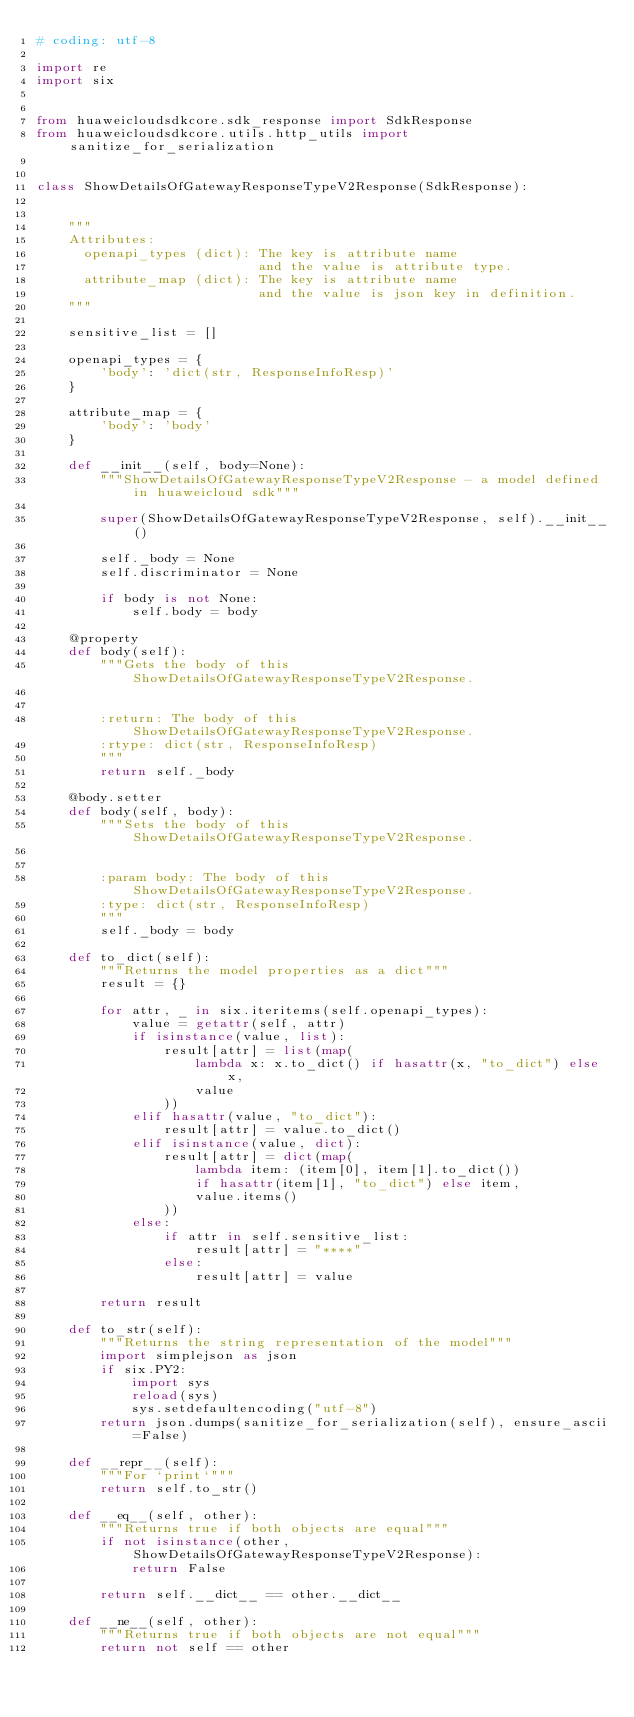<code> <loc_0><loc_0><loc_500><loc_500><_Python_># coding: utf-8

import re
import six


from huaweicloudsdkcore.sdk_response import SdkResponse
from huaweicloudsdkcore.utils.http_utils import sanitize_for_serialization


class ShowDetailsOfGatewayResponseTypeV2Response(SdkResponse):


    """
    Attributes:
      openapi_types (dict): The key is attribute name
                            and the value is attribute type.
      attribute_map (dict): The key is attribute name
                            and the value is json key in definition.
    """

    sensitive_list = []

    openapi_types = {
        'body': 'dict(str, ResponseInfoResp)'
    }

    attribute_map = {
        'body': 'body'
    }

    def __init__(self, body=None):
        """ShowDetailsOfGatewayResponseTypeV2Response - a model defined in huaweicloud sdk"""
        
        super(ShowDetailsOfGatewayResponseTypeV2Response, self).__init__()

        self._body = None
        self.discriminator = None

        if body is not None:
            self.body = body

    @property
    def body(self):
        """Gets the body of this ShowDetailsOfGatewayResponseTypeV2Response.


        :return: The body of this ShowDetailsOfGatewayResponseTypeV2Response.
        :rtype: dict(str, ResponseInfoResp)
        """
        return self._body

    @body.setter
    def body(self, body):
        """Sets the body of this ShowDetailsOfGatewayResponseTypeV2Response.


        :param body: The body of this ShowDetailsOfGatewayResponseTypeV2Response.
        :type: dict(str, ResponseInfoResp)
        """
        self._body = body

    def to_dict(self):
        """Returns the model properties as a dict"""
        result = {}

        for attr, _ in six.iteritems(self.openapi_types):
            value = getattr(self, attr)
            if isinstance(value, list):
                result[attr] = list(map(
                    lambda x: x.to_dict() if hasattr(x, "to_dict") else x,
                    value
                ))
            elif hasattr(value, "to_dict"):
                result[attr] = value.to_dict()
            elif isinstance(value, dict):
                result[attr] = dict(map(
                    lambda item: (item[0], item[1].to_dict())
                    if hasattr(item[1], "to_dict") else item,
                    value.items()
                ))
            else:
                if attr in self.sensitive_list:
                    result[attr] = "****"
                else:
                    result[attr] = value

        return result

    def to_str(self):
        """Returns the string representation of the model"""
        import simplejson as json
        if six.PY2:
            import sys
            reload(sys)
            sys.setdefaultencoding("utf-8")
        return json.dumps(sanitize_for_serialization(self), ensure_ascii=False)

    def __repr__(self):
        """For `print`"""
        return self.to_str()

    def __eq__(self, other):
        """Returns true if both objects are equal"""
        if not isinstance(other, ShowDetailsOfGatewayResponseTypeV2Response):
            return False

        return self.__dict__ == other.__dict__

    def __ne__(self, other):
        """Returns true if both objects are not equal"""
        return not self == other
</code> 